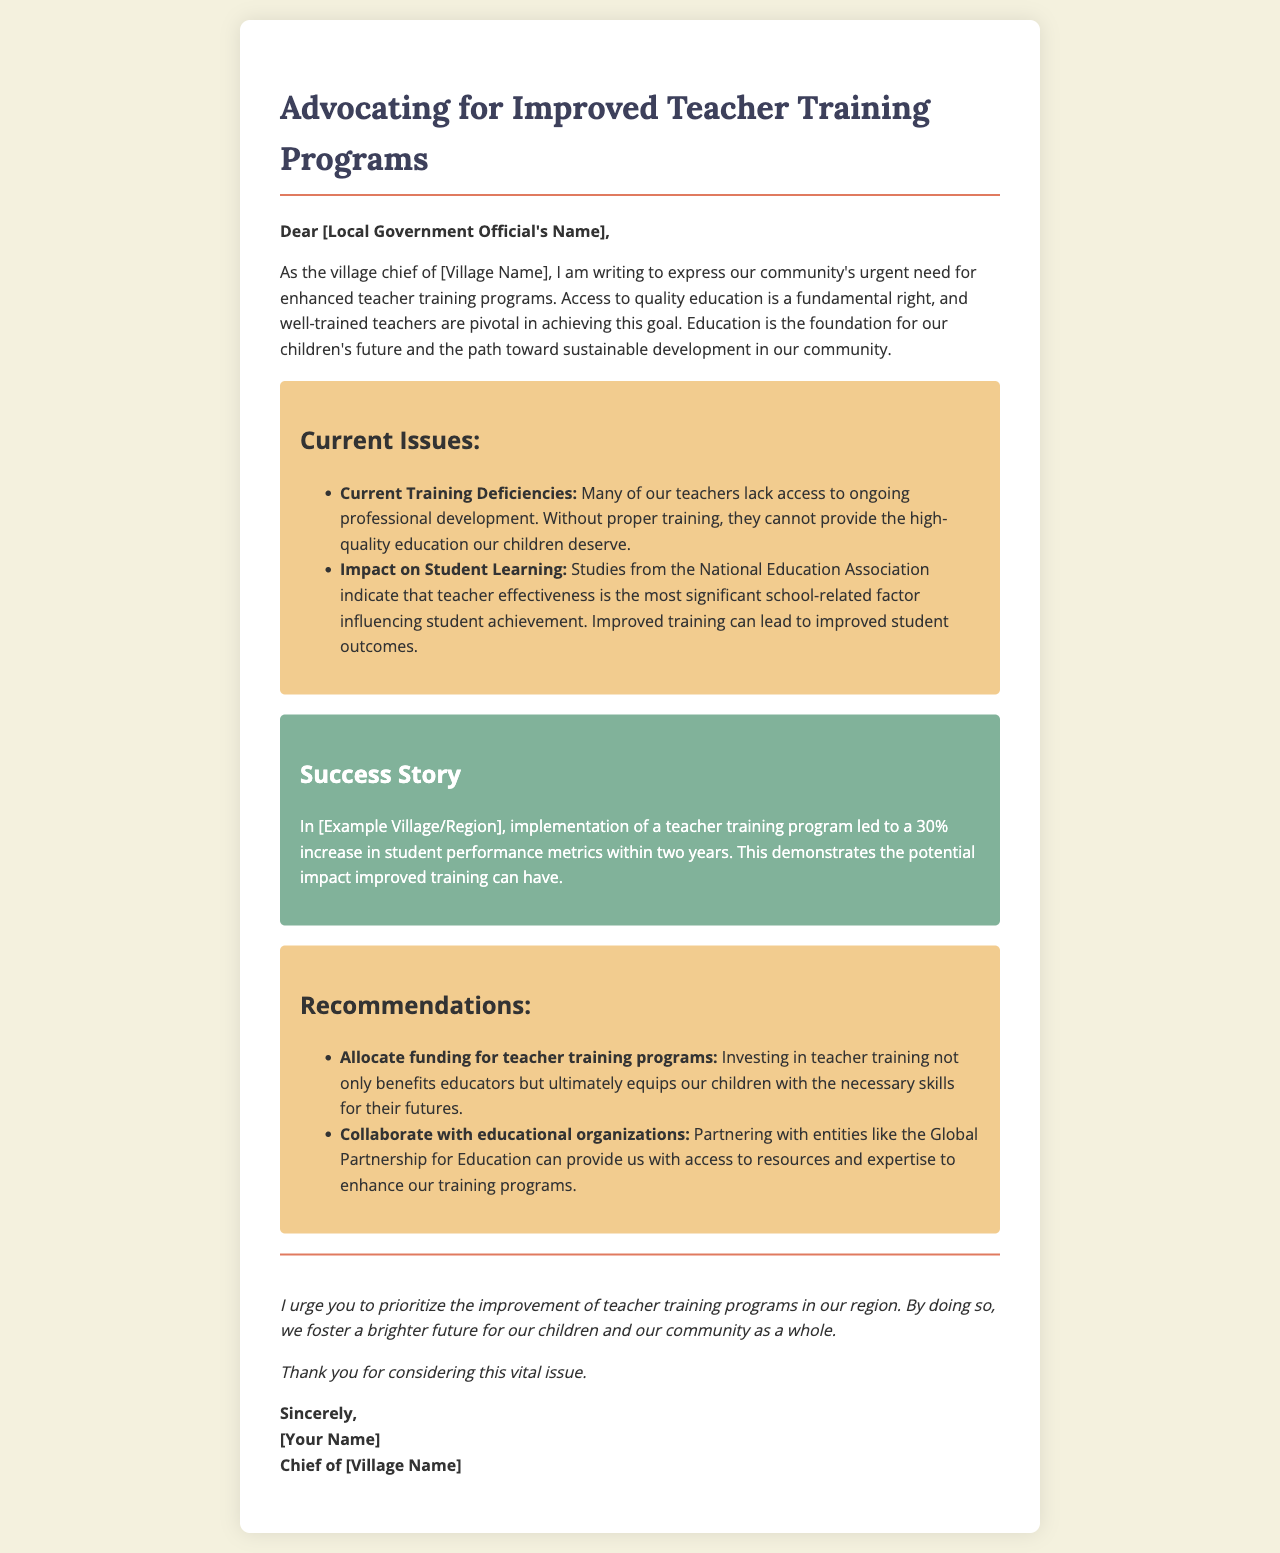What is the title of the document? The title is mentioned at the top of the letter, indicating the main focus of the content.
Answer: Advocating for Improved Teacher Training Programs Who is the letter addressed to? The greeting section identifies the recipient by their title, indicating the target audience for the letter.
Answer: [Local Government Official's Name] What is one current issue highlighted in the document? The document lists specific issues under a section, providing insight into the challenges faced by teachers in the community.
Answer: Current Training Deficiencies What is the percentage increase in student performance mentioned in the success story? The case study section provides evidence from a specific example, quantifying the positive effect of teacher training.
Answer: 30% What is one recommendation given in the document? The recommendations section lists actionable steps to address the issues discussed, offering practical solutions.
Answer: Allocate funding for teacher training programs What is emphasized as the most significant school-related factor influencing student achievement? The document cites a credible source to highlight the relationship between teacher effectiveness and student outcomes.
Answer: teacher effectiveness What benefits are mentioned for investing in teacher training? The letter discusses the broader impact of teacher training on both educators and children, emphasizing long-term benefits.
Answer: equips our children with the necessary skills for their futures What is the role of the sender of the letter? The closing section identifies the senders title, which provides context about their authority and perspective in this matter.
Answer: Chief of [Village Name] 